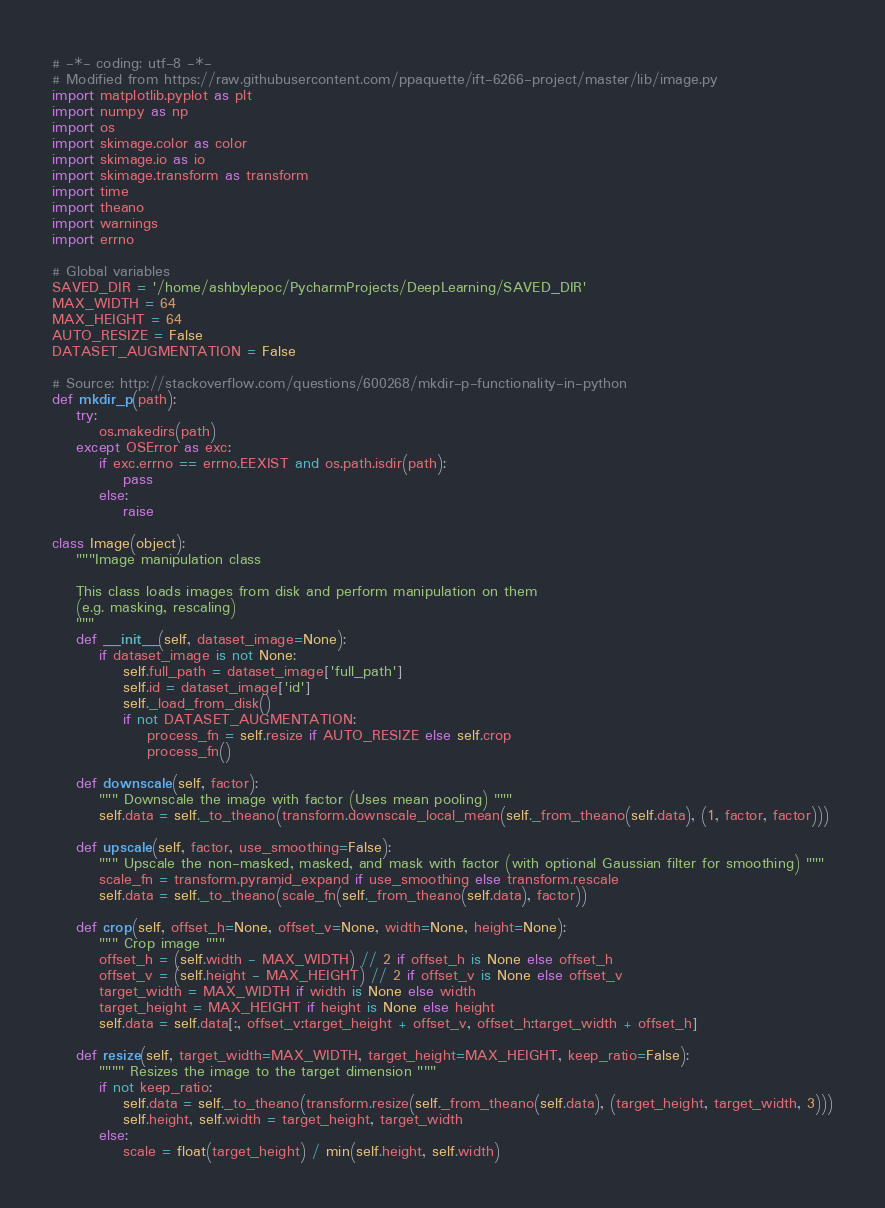Convert code to text. <code><loc_0><loc_0><loc_500><loc_500><_Python_># -*- coding: utf-8 -*-
# Modified from https://raw.githubusercontent.com/ppaquette/ift-6266-project/master/lib/image.py
import matplotlib.pyplot as plt
import numpy as np
import os
import skimage.color as color
import skimage.io as io
import skimage.transform as transform
import time
import theano
import warnings
import errno

# Global variables
SAVED_DIR = '/home/ashbylepoc/PycharmProjects/DeepLearning/SAVED_DIR'
MAX_WIDTH = 64
MAX_HEIGHT = 64
AUTO_RESIZE = False
DATASET_AUGMENTATION = False

# Source: http://stackoverflow.com/questions/600268/mkdir-p-functionality-in-python
def mkdir_p(path):
    try:
        os.makedirs(path)
    except OSError as exc:
        if exc.errno == errno.EEXIST and os.path.isdir(path):
            pass
        else:
            raise

class Image(object):
    """Image manipulation class

    This class loads images from disk and perform manipulation on them
    (e.g. masking, rescaling)
    """
    def __init__(self, dataset_image=None):
        if dataset_image is not None:
            self.full_path = dataset_image['full_path']
            self.id = dataset_image['id']
            self._load_from_disk()
            if not DATASET_AUGMENTATION:
                process_fn = self.resize if AUTO_RESIZE else self.crop
                process_fn()

    def downscale(self, factor):
        """ Downscale the image with factor (Uses mean pooling) """
        self.data = self._to_theano(transform.downscale_local_mean(self._from_theano(self.data), (1, factor, factor)))

    def upscale(self, factor, use_smoothing=False):
        """ Upscale the non-masked, masked, and mask with factor (with optional Gaussian filter for smoothing) """
        scale_fn = transform.pyramid_expand if use_smoothing else transform.rescale
        self.data = self._to_theano(scale_fn(self._from_theano(self.data), factor))

    def crop(self, offset_h=None, offset_v=None, width=None, height=None):
        """ Crop image """
        offset_h = (self.width - MAX_WIDTH) // 2 if offset_h is None else offset_h
        offset_v = (self.height - MAX_HEIGHT) // 2 if offset_v is None else offset_v
        target_width = MAX_WIDTH if width is None else width
        target_height = MAX_HEIGHT if height is None else height
        self.data = self.data[:, offset_v:target_height + offset_v, offset_h:target_width + offset_h]

    def resize(self, target_width=MAX_WIDTH, target_height=MAX_HEIGHT, keep_ratio=False):
        """" Resizes the image to the target dimension """
        if not keep_ratio:
            self.data = self._to_theano(transform.resize(self._from_theano(self.data), (target_height, target_width, 3)))
            self.height, self.width = target_height, target_width
        else:
            scale = float(target_height) / min(self.height, self.width)</code> 